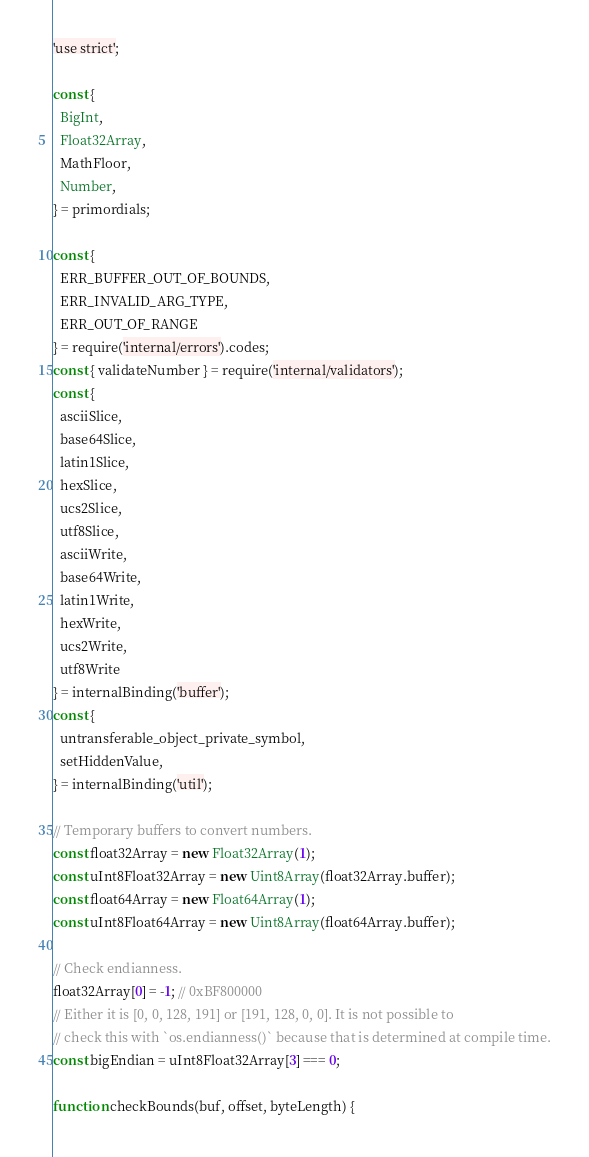<code> <loc_0><loc_0><loc_500><loc_500><_JavaScript_>'use strict';

const {
  BigInt,
  Float32Array,
  MathFloor,
  Number,
} = primordials;

const {
  ERR_BUFFER_OUT_OF_BOUNDS,
  ERR_INVALID_ARG_TYPE,
  ERR_OUT_OF_RANGE
} = require('internal/errors').codes;
const { validateNumber } = require('internal/validators');
const {
  asciiSlice,
  base64Slice,
  latin1Slice,
  hexSlice,
  ucs2Slice,
  utf8Slice,
  asciiWrite,
  base64Write,
  latin1Write,
  hexWrite,
  ucs2Write,
  utf8Write
} = internalBinding('buffer');
const {
  untransferable_object_private_symbol,
  setHiddenValue,
} = internalBinding('util');

// Temporary buffers to convert numbers.
const float32Array = new Float32Array(1);
const uInt8Float32Array = new Uint8Array(float32Array.buffer);
const float64Array = new Float64Array(1);
const uInt8Float64Array = new Uint8Array(float64Array.buffer);

// Check endianness.
float32Array[0] = -1; // 0xBF800000
// Either it is [0, 0, 128, 191] or [191, 128, 0, 0]. It is not possible to
// check this with `os.endianness()` because that is determined at compile time.
const bigEndian = uInt8Float32Array[3] === 0;

function checkBounds(buf, offset, byteLength) {</code> 